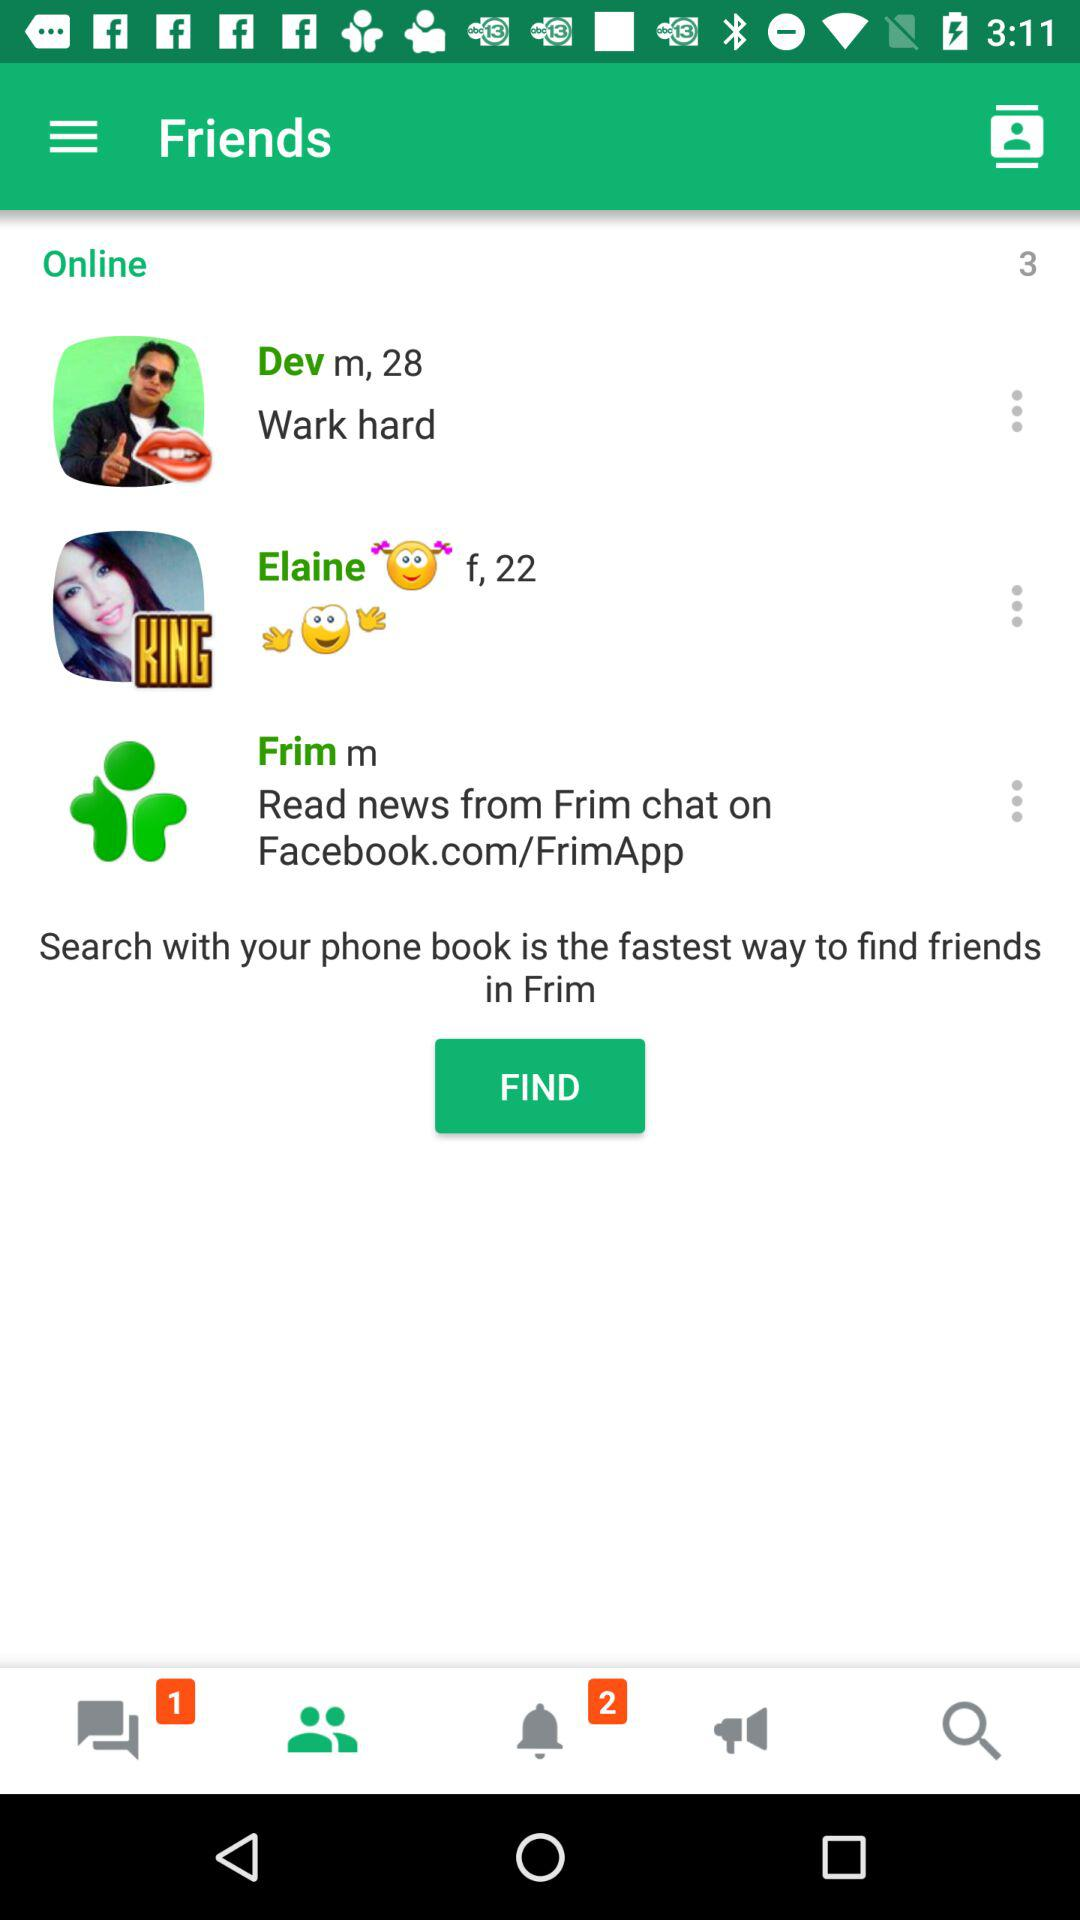How many unread notifications are shown there? There are 2 unread notifications. 